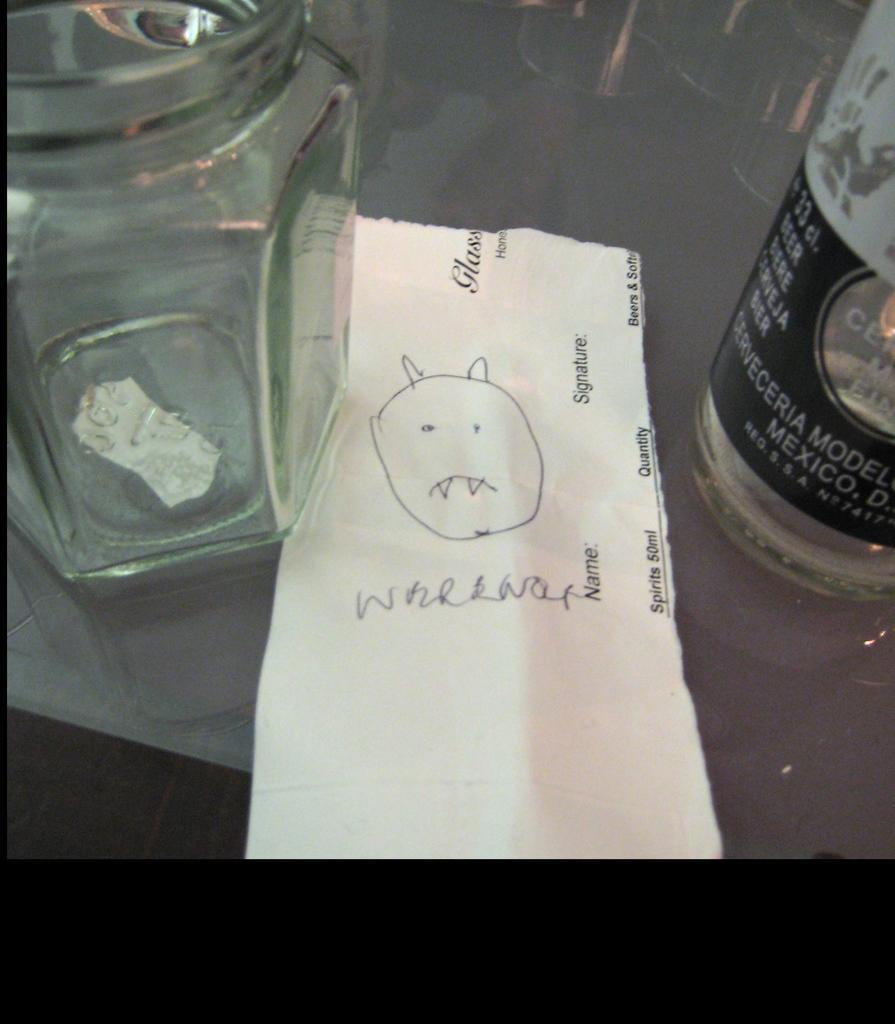How would you summarize this image in a sentence or two? In this picture there is a jar on the left side and bottle on the right side. In middle of them, there is a paper and some doodles on it. 